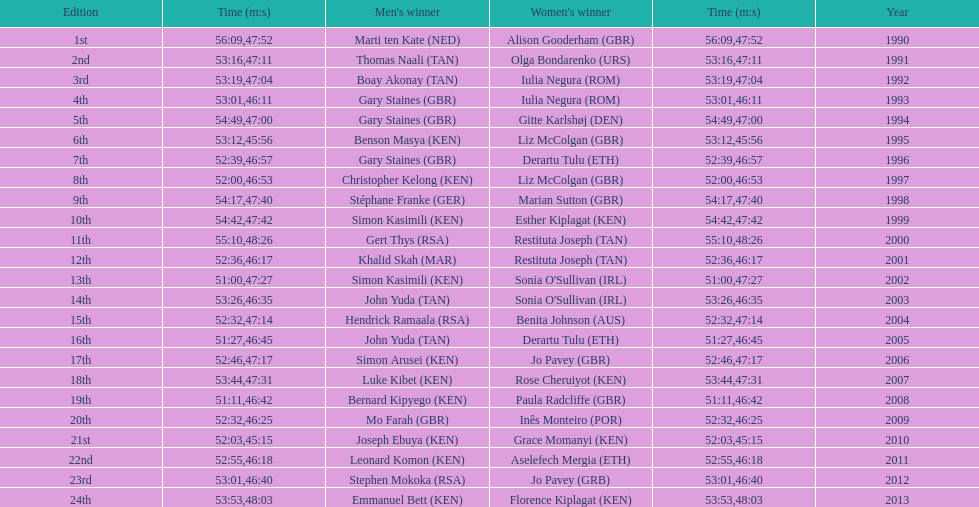Home many times did a single country win both the men's and women's bupa great south run? 4. 